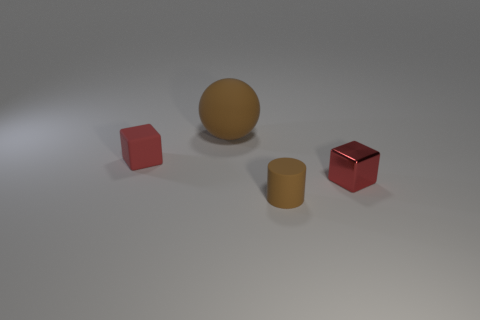What is the material of the red cube that is on the left side of the matte object that is in front of the block behind the small shiny block? Based on the visual cues present in the image, the red cube on the left of the matte object appears to be made of a rubber-like material. Its texture is indicative of a soft, non-reflective surface which is characteristic of rubber items. 